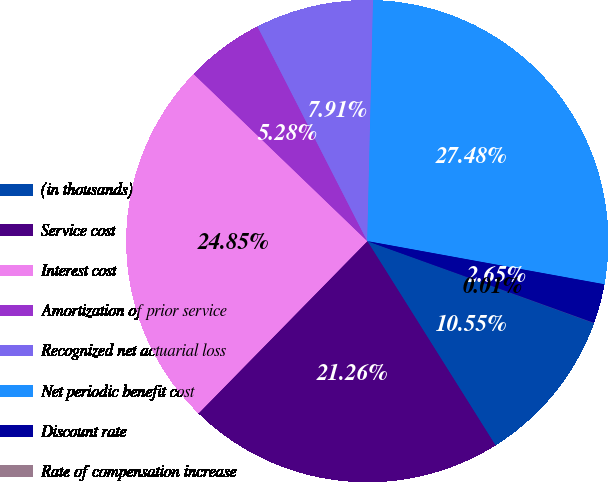Convert chart. <chart><loc_0><loc_0><loc_500><loc_500><pie_chart><fcel>(in thousands)<fcel>Service cost<fcel>Interest cost<fcel>Amortization of prior service<fcel>Recognized net actuarial loss<fcel>Net periodic benefit cost<fcel>Discount rate<fcel>Rate of compensation increase<nl><fcel>10.55%<fcel>21.26%<fcel>24.85%<fcel>5.28%<fcel>7.91%<fcel>27.48%<fcel>2.65%<fcel>0.01%<nl></chart> 